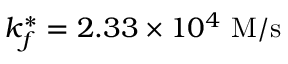<formula> <loc_0><loc_0><loc_500><loc_500>k _ { f } ^ { * } = 2 . 3 3 \times 1 0 ^ { 4 } M / s</formula> 